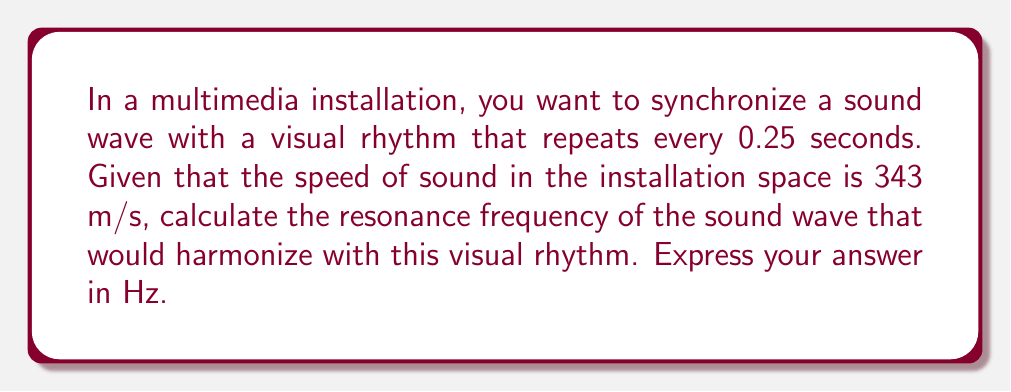What is the answer to this math problem? To solve this problem, we need to understand the relationship between frequency, wavelength, and the speed of sound. We'll follow these steps:

1. Determine the period of the visual rhythm:
   The visual rhythm repeats every 0.25 seconds, so this is our period (T).

2. Calculate the frequency of the visual rhythm:
   Frequency (f) is the inverse of the period (T).
   $$f = \frac{1}{T} = \frac{1}{0.25} = 4 \text{ Hz}$$

3. To synchronize, the sound wave should have the same frequency or a harmonic of this frequency. Let's use the fundamental frequency of 4 Hz.

4. Use the wave equation to find the wavelength:
   $$v = f\lambda$$
   Where:
   $v$ is the speed of sound (343 m/s)
   $f$ is the frequency (4 Hz)
   $\lambda$ is the wavelength

   Rearranging the equation:
   $$\lambda = \frac{v}{f} = \frac{343}{4} = 85.75 \text{ m}$$

5. The resonance frequency is determined by the length of the resonating chamber. For a closed-end resonator, the fundamental resonance occurs when the length of the chamber is 1/4 of the wavelength. So, we need to find the frequency that corresponds to a wavelength of $\frac{85.75}{4} = 21.4375 \text{ m}$.

6. Using the wave equation again:
   $$f_{\text{resonance}} = \frac{v}{\lambda} = \frac{343}{21.4375} = 16 \text{ Hz}$$

This resonance frequency is exactly 4 times the visual rhythm frequency, making it the 4th harmonic, which will synchronize perfectly with the visual element.
Answer: 16 Hz 